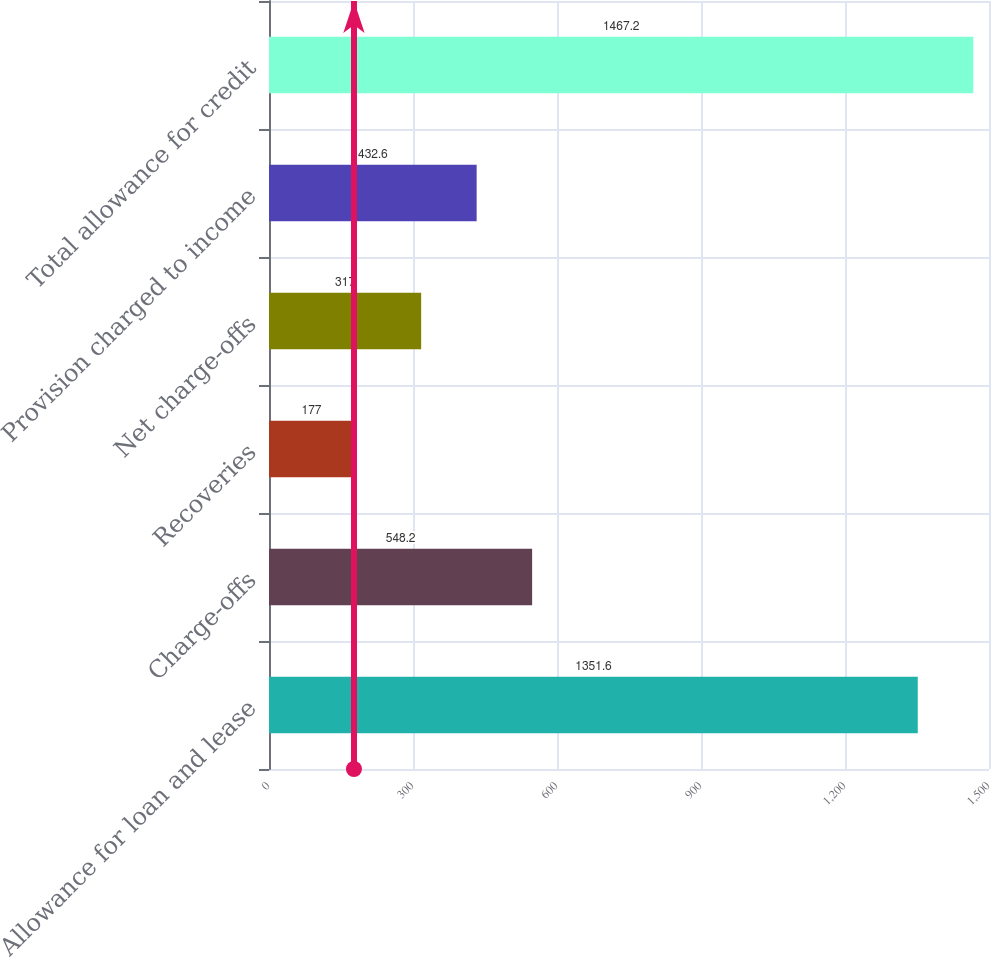Convert chart. <chart><loc_0><loc_0><loc_500><loc_500><bar_chart><fcel>Allowance for loan and lease<fcel>Charge-offs<fcel>Recoveries<fcel>Net charge-offs<fcel>Provision charged to income<fcel>Total allowance for credit<nl><fcel>1351.6<fcel>548.2<fcel>177<fcel>317<fcel>432.6<fcel>1467.2<nl></chart> 